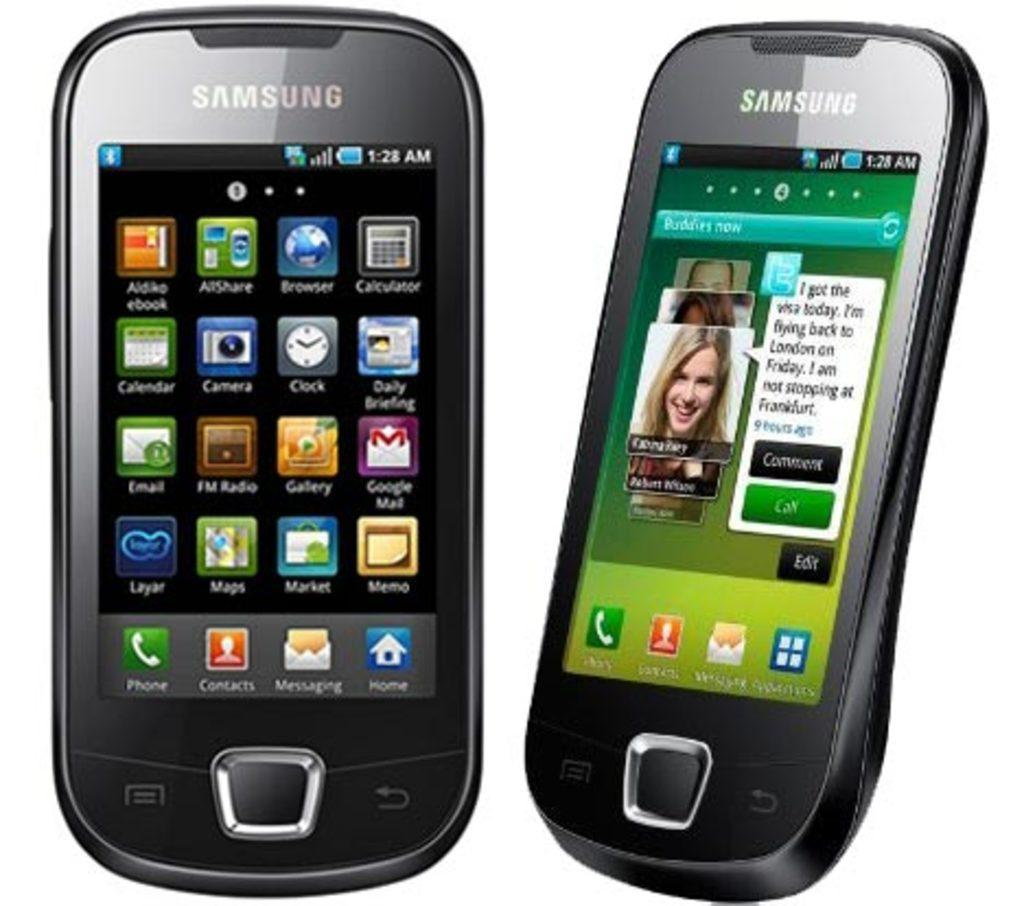Provide a one-sentence caption for the provided image. two Samsung cell phones open to icon screens like Buddies Now. 